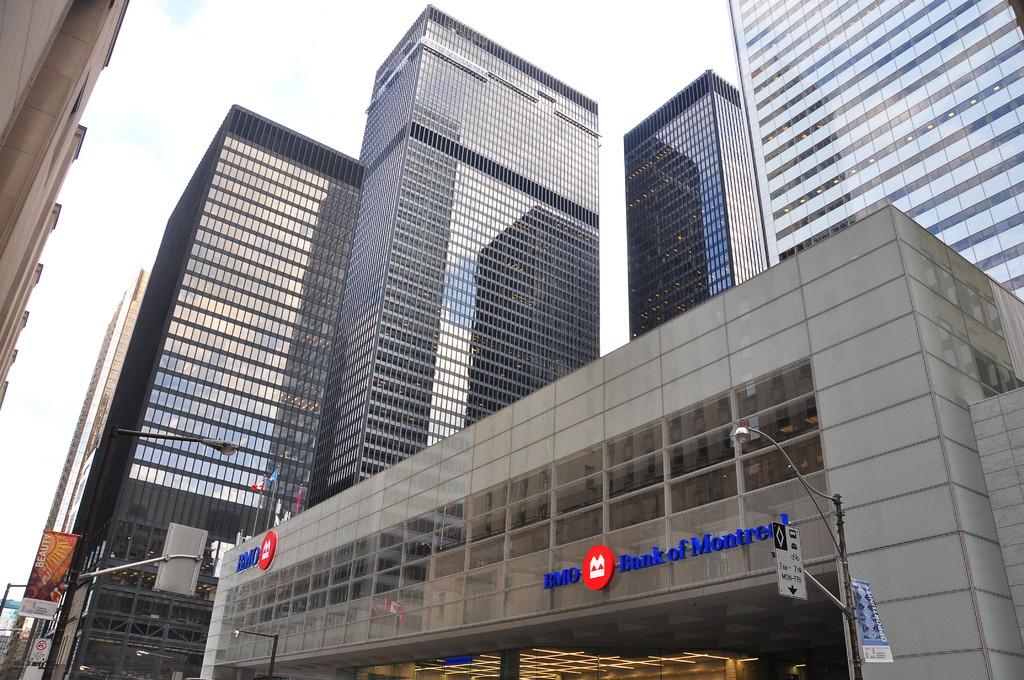What bank is shown here?
Your answer should be very brief. Bank of montreal. 